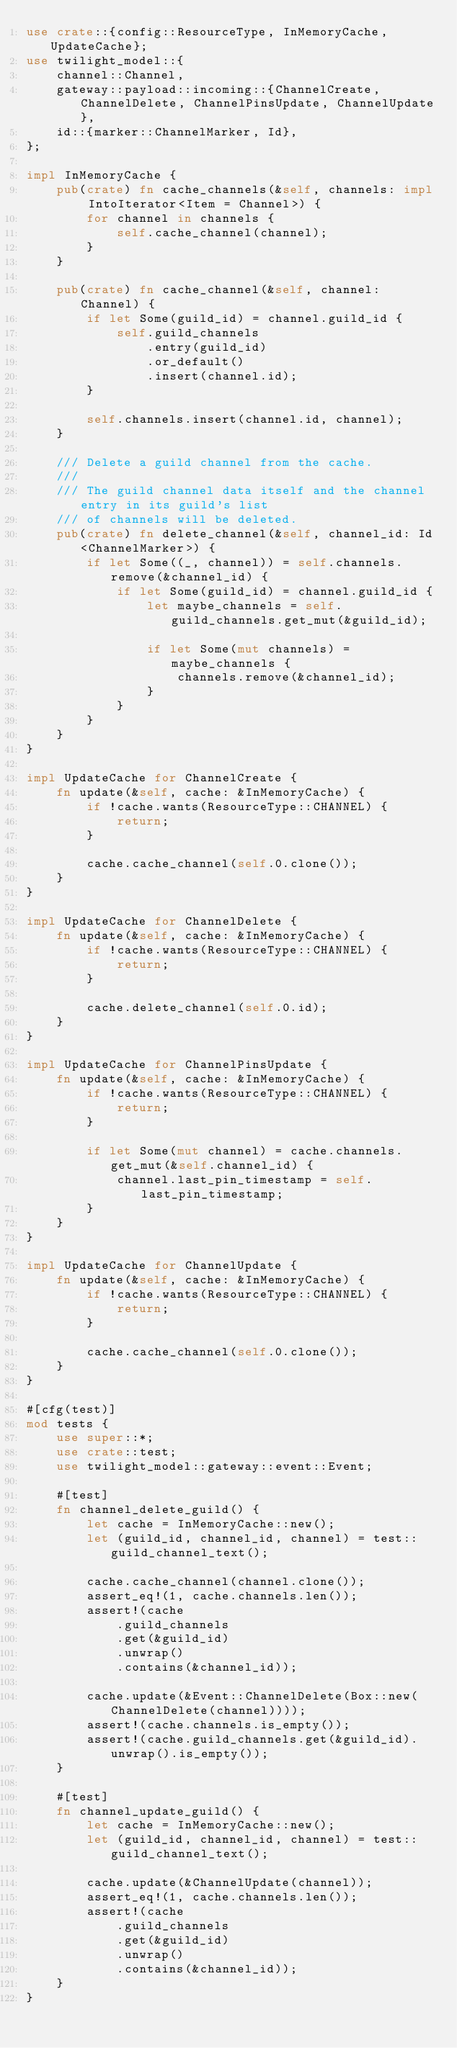<code> <loc_0><loc_0><loc_500><loc_500><_Rust_>use crate::{config::ResourceType, InMemoryCache, UpdateCache};
use twilight_model::{
    channel::Channel,
    gateway::payload::incoming::{ChannelCreate, ChannelDelete, ChannelPinsUpdate, ChannelUpdate},
    id::{marker::ChannelMarker, Id},
};

impl InMemoryCache {
    pub(crate) fn cache_channels(&self, channels: impl IntoIterator<Item = Channel>) {
        for channel in channels {
            self.cache_channel(channel);
        }
    }

    pub(crate) fn cache_channel(&self, channel: Channel) {
        if let Some(guild_id) = channel.guild_id {
            self.guild_channels
                .entry(guild_id)
                .or_default()
                .insert(channel.id);
        }

        self.channels.insert(channel.id, channel);
    }

    /// Delete a guild channel from the cache.
    ///
    /// The guild channel data itself and the channel entry in its guild's list
    /// of channels will be deleted.
    pub(crate) fn delete_channel(&self, channel_id: Id<ChannelMarker>) {
        if let Some((_, channel)) = self.channels.remove(&channel_id) {
            if let Some(guild_id) = channel.guild_id {
                let maybe_channels = self.guild_channels.get_mut(&guild_id);

                if let Some(mut channels) = maybe_channels {
                    channels.remove(&channel_id);
                }
            }
        }
    }
}

impl UpdateCache for ChannelCreate {
    fn update(&self, cache: &InMemoryCache) {
        if !cache.wants(ResourceType::CHANNEL) {
            return;
        }

        cache.cache_channel(self.0.clone());
    }
}

impl UpdateCache for ChannelDelete {
    fn update(&self, cache: &InMemoryCache) {
        if !cache.wants(ResourceType::CHANNEL) {
            return;
        }

        cache.delete_channel(self.0.id);
    }
}

impl UpdateCache for ChannelPinsUpdate {
    fn update(&self, cache: &InMemoryCache) {
        if !cache.wants(ResourceType::CHANNEL) {
            return;
        }

        if let Some(mut channel) = cache.channels.get_mut(&self.channel_id) {
            channel.last_pin_timestamp = self.last_pin_timestamp;
        }
    }
}

impl UpdateCache for ChannelUpdate {
    fn update(&self, cache: &InMemoryCache) {
        if !cache.wants(ResourceType::CHANNEL) {
            return;
        }

        cache.cache_channel(self.0.clone());
    }
}

#[cfg(test)]
mod tests {
    use super::*;
    use crate::test;
    use twilight_model::gateway::event::Event;

    #[test]
    fn channel_delete_guild() {
        let cache = InMemoryCache::new();
        let (guild_id, channel_id, channel) = test::guild_channel_text();

        cache.cache_channel(channel.clone());
        assert_eq!(1, cache.channels.len());
        assert!(cache
            .guild_channels
            .get(&guild_id)
            .unwrap()
            .contains(&channel_id));

        cache.update(&Event::ChannelDelete(Box::new(ChannelDelete(channel))));
        assert!(cache.channels.is_empty());
        assert!(cache.guild_channels.get(&guild_id).unwrap().is_empty());
    }

    #[test]
    fn channel_update_guild() {
        let cache = InMemoryCache::new();
        let (guild_id, channel_id, channel) = test::guild_channel_text();

        cache.update(&ChannelUpdate(channel));
        assert_eq!(1, cache.channels.len());
        assert!(cache
            .guild_channels
            .get(&guild_id)
            .unwrap()
            .contains(&channel_id));
    }
}
</code> 